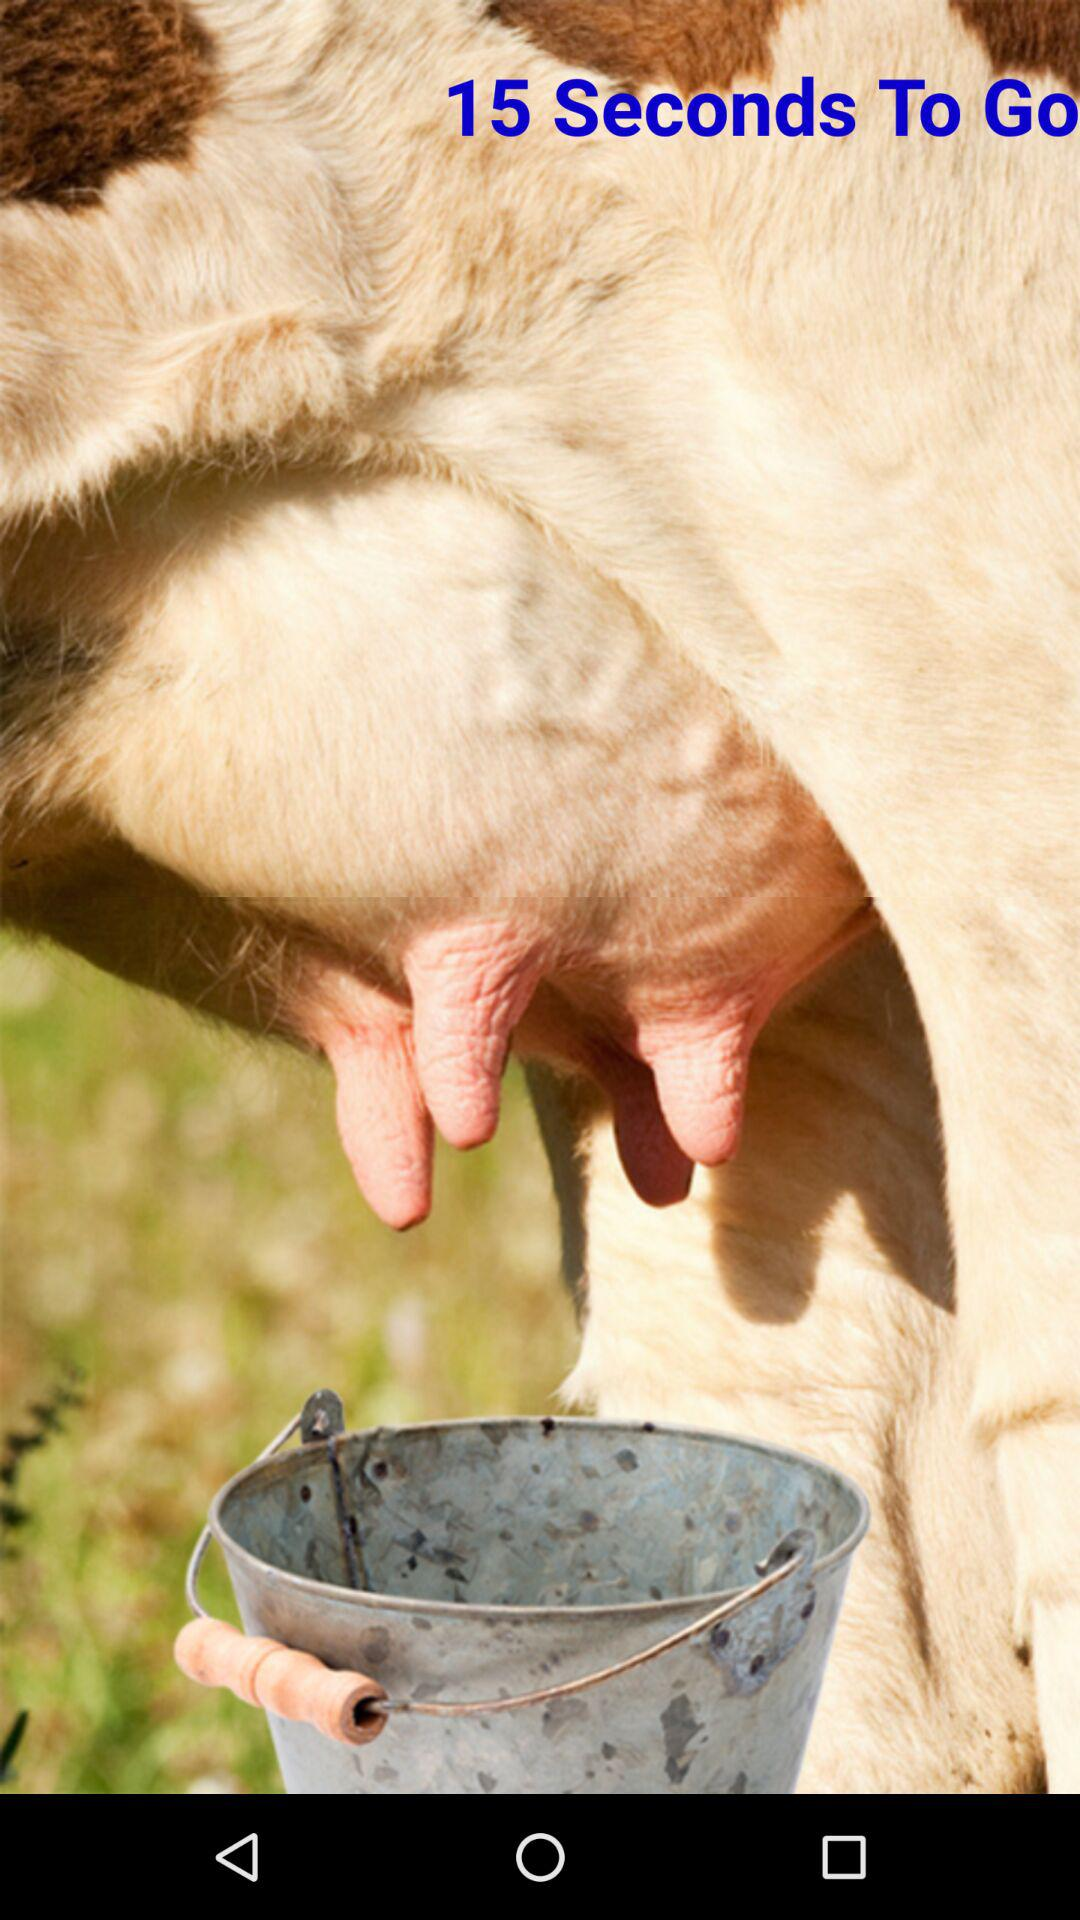How many seconds are there to go? There are 15 seconds to go. 